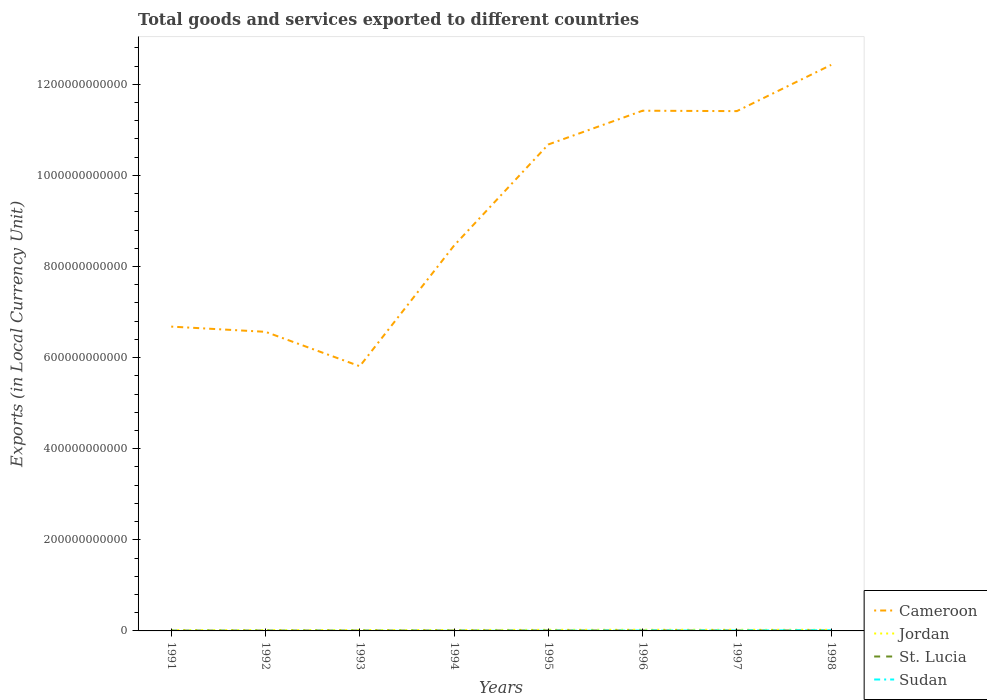Does the line corresponding to Jordan intersect with the line corresponding to St. Lucia?
Offer a very short reply. No. Is the number of lines equal to the number of legend labels?
Your answer should be compact. Yes. Across all years, what is the maximum Amount of goods and services exports in Cameroon?
Give a very brief answer. 5.81e+11. In which year was the Amount of goods and services exports in Cameroon maximum?
Give a very brief answer. 1993. What is the total Amount of goods and services exports in Jordan in the graph?
Ensure brevity in your answer.  -4.83e+08. What is the difference between the highest and the second highest Amount of goods and services exports in St. Lucia?
Provide a short and direct response. 2.23e+08. What is the difference between the highest and the lowest Amount of goods and services exports in Sudan?
Provide a short and direct response. 3. Is the Amount of goods and services exports in Sudan strictly greater than the Amount of goods and services exports in Cameroon over the years?
Provide a short and direct response. Yes. How many years are there in the graph?
Offer a terse response. 8. What is the difference between two consecutive major ticks on the Y-axis?
Offer a terse response. 2.00e+11. Does the graph contain grids?
Offer a terse response. No. How many legend labels are there?
Keep it short and to the point. 4. What is the title of the graph?
Ensure brevity in your answer.  Total goods and services exported to different countries. Does "Turks and Caicos Islands" appear as one of the legend labels in the graph?
Give a very brief answer. No. What is the label or title of the X-axis?
Offer a terse response. Years. What is the label or title of the Y-axis?
Provide a succinct answer. Exports (in Local Currency Unit). What is the Exports (in Local Currency Unit) in Cameroon in 1991?
Make the answer very short. 6.68e+11. What is the Exports (in Local Currency Unit) of Jordan in 1991?
Provide a succinct answer. 1.70e+09. What is the Exports (in Local Currency Unit) in St. Lucia in 1991?
Your answer should be very brief. 8.15e+08. What is the Exports (in Local Currency Unit) in Sudan in 1991?
Keep it short and to the point. 1.02e+07. What is the Exports (in Local Currency Unit) of Cameroon in 1992?
Make the answer very short. 6.57e+11. What is the Exports (in Local Currency Unit) in Jordan in 1992?
Ensure brevity in your answer.  1.81e+09. What is the Exports (in Local Currency Unit) in St. Lucia in 1992?
Your answer should be very brief. 8.74e+08. What is the Exports (in Local Currency Unit) of Sudan in 1992?
Your answer should be very brief. 3.59e+07. What is the Exports (in Local Currency Unit) in Cameroon in 1993?
Give a very brief answer. 5.81e+11. What is the Exports (in Local Currency Unit) of Jordan in 1993?
Provide a succinct answer. 1.96e+09. What is the Exports (in Local Currency Unit) of St. Lucia in 1993?
Provide a succinct answer. 8.99e+08. What is the Exports (in Local Currency Unit) in Sudan in 1993?
Keep it short and to the point. 5.99e+07. What is the Exports (in Local Currency Unit) of Cameroon in 1994?
Keep it short and to the point. 8.46e+11. What is the Exports (in Local Currency Unit) in Jordan in 1994?
Make the answer very short. 2.09e+09. What is the Exports (in Local Currency Unit) of St. Lucia in 1994?
Ensure brevity in your answer.  9.18e+08. What is the Exports (in Local Currency Unit) in Sudan in 1994?
Your answer should be compact. 1.74e+08. What is the Exports (in Local Currency Unit) in Cameroon in 1995?
Your answer should be very brief. 1.07e+12. What is the Exports (in Local Currency Unit) in Jordan in 1995?
Give a very brief answer. 2.44e+09. What is the Exports (in Local Currency Unit) of St. Lucia in 1995?
Make the answer very short. 1.02e+09. What is the Exports (in Local Currency Unit) of Sudan in 1995?
Ensure brevity in your answer.  3.99e+08. What is the Exports (in Local Currency Unit) in Cameroon in 1996?
Ensure brevity in your answer.  1.14e+12. What is the Exports (in Local Currency Unit) in Jordan in 1996?
Provide a short and direct response. 2.60e+09. What is the Exports (in Local Currency Unit) in St. Lucia in 1996?
Ensure brevity in your answer.  9.53e+08. What is the Exports (in Local Currency Unit) in Sudan in 1996?
Offer a very short reply. 8.41e+08. What is the Exports (in Local Currency Unit) in Cameroon in 1997?
Provide a short and direct response. 1.14e+12. What is the Exports (in Local Currency Unit) of Jordan in 1997?
Provide a short and direct response. 2.53e+09. What is the Exports (in Local Currency Unit) of St. Lucia in 1997?
Your answer should be very brief. 9.68e+08. What is the Exports (in Local Currency Unit) in Sudan in 1997?
Offer a very short reply. 9.84e+08. What is the Exports (in Local Currency Unit) in Cameroon in 1998?
Make the answer very short. 1.24e+12. What is the Exports (in Local Currency Unit) of Jordan in 1998?
Provide a short and direct response. 2.52e+09. What is the Exports (in Local Currency Unit) in St. Lucia in 1998?
Provide a short and direct response. 1.04e+09. What is the Exports (in Local Currency Unit) of Sudan in 1998?
Ensure brevity in your answer.  1.51e+09. Across all years, what is the maximum Exports (in Local Currency Unit) of Cameroon?
Ensure brevity in your answer.  1.24e+12. Across all years, what is the maximum Exports (in Local Currency Unit) of Jordan?
Ensure brevity in your answer.  2.60e+09. Across all years, what is the maximum Exports (in Local Currency Unit) of St. Lucia?
Give a very brief answer. 1.04e+09. Across all years, what is the maximum Exports (in Local Currency Unit) of Sudan?
Provide a short and direct response. 1.51e+09. Across all years, what is the minimum Exports (in Local Currency Unit) of Cameroon?
Offer a very short reply. 5.81e+11. Across all years, what is the minimum Exports (in Local Currency Unit) in Jordan?
Make the answer very short. 1.70e+09. Across all years, what is the minimum Exports (in Local Currency Unit) in St. Lucia?
Make the answer very short. 8.15e+08. Across all years, what is the minimum Exports (in Local Currency Unit) in Sudan?
Make the answer very short. 1.02e+07. What is the total Exports (in Local Currency Unit) in Cameroon in the graph?
Your answer should be compact. 7.34e+12. What is the total Exports (in Local Currency Unit) of Jordan in the graph?
Your response must be concise. 1.76e+1. What is the total Exports (in Local Currency Unit) of St. Lucia in the graph?
Provide a short and direct response. 7.49e+09. What is the total Exports (in Local Currency Unit) of Sudan in the graph?
Your answer should be compact. 4.02e+09. What is the difference between the Exports (in Local Currency Unit) in Cameroon in 1991 and that in 1992?
Offer a terse response. 1.15e+1. What is the difference between the Exports (in Local Currency Unit) of Jordan in 1991 and that in 1992?
Make the answer very short. -1.16e+08. What is the difference between the Exports (in Local Currency Unit) of St. Lucia in 1991 and that in 1992?
Offer a very short reply. -5.97e+07. What is the difference between the Exports (in Local Currency Unit) in Sudan in 1991 and that in 1992?
Offer a terse response. -2.57e+07. What is the difference between the Exports (in Local Currency Unit) in Cameroon in 1991 and that in 1993?
Ensure brevity in your answer.  8.70e+1. What is the difference between the Exports (in Local Currency Unit) of Jordan in 1991 and that in 1993?
Your answer should be compact. -2.58e+08. What is the difference between the Exports (in Local Currency Unit) of St. Lucia in 1991 and that in 1993?
Provide a succinct answer. -8.42e+07. What is the difference between the Exports (in Local Currency Unit) of Sudan in 1991 and that in 1993?
Give a very brief answer. -4.96e+07. What is the difference between the Exports (in Local Currency Unit) of Cameroon in 1991 and that in 1994?
Your answer should be compact. -1.78e+11. What is the difference between the Exports (in Local Currency Unit) in Jordan in 1991 and that in 1994?
Ensure brevity in your answer.  -3.88e+08. What is the difference between the Exports (in Local Currency Unit) of St. Lucia in 1991 and that in 1994?
Keep it short and to the point. -1.03e+08. What is the difference between the Exports (in Local Currency Unit) of Sudan in 1991 and that in 1994?
Give a very brief answer. -1.64e+08. What is the difference between the Exports (in Local Currency Unit) of Cameroon in 1991 and that in 1995?
Offer a terse response. -4.00e+11. What is the difference between the Exports (in Local Currency Unit) of Jordan in 1991 and that in 1995?
Provide a short and direct response. -7.41e+08. What is the difference between the Exports (in Local Currency Unit) of St. Lucia in 1991 and that in 1995?
Offer a very short reply. -2.08e+08. What is the difference between the Exports (in Local Currency Unit) in Sudan in 1991 and that in 1995?
Make the answer very short. -3.89e+08. What is the difference between the Exports (in Local Currency Unit) in Cameroon in 1991 and that in 1996?
Your answer should be very brief. -4.74e+11. What is the difference between the Exports (in Local Currency Unit) in Jordan in 1991 and that in 1996?
Keep it short and to the point. -9.00e+08. What is the difference between the Exports (in Local Currency Unit) in St. Lucia in 1991 and that in 1996?
Your answer should be very brief. -1.39e+08. What is the difference between the Exports (in Local Currency Unit) in Sudan in 1991 and that in 1996?
Offer a terse response. -8.31e+08. What is the difference between the Exports (in Local Currency Unit) in Cameroon in 1991 and that in 1997?
Provide a succinct answer. -4.73e+11. What is the difference between the Exports (in Local Currency Unit) of Jordan in 1991 and that in 1997?
Your response must be concise. -8.35e+08. What is the difference between the Exports (in Local Currency Unit) in St. Lucia in 1991 and that in 1997?
Your answer should be compact. -1.54e+08. What is the difference between the Exports (in Local Currency Unit) in Sudan in 1991 and that in 1997?
Your response must be concise. -9.73e+08. What is the difference between the Exports (in Local Currency Unit) of Cameroon in 1991 and that in 1998?
Give a very brief answer. -5.75e+11. What is the difference between the Exports (in Local Currency Unit) of Jordan in 1991 and that in 1998?
Offer a very short reply. -8.18e+08. What is the difference between the Exports (in Local Currency Unit) of St. Lucia in 1991 and that in 1998?
Your response must be concise. -2.23e+08. What is the difference between the Exports (in Local Currency Unit) of Sudan in 1991 and that in 1998?
Offer a very short reply. -1.50e+09. What is the difference between the Exports (in Local Currency Unit) of Cameroon in 1992 and that in 1993?
Ensure brevity in your answer.  7.55e+1. What is the difference between the Exports (in Local Currency Unit) of Jordan in 1992 and that in 1993?
Offer a terse response. -1.42e+08. What is the difference between the Exports (in Local Currency Unit) in St. Lucia in 1992 and that in 1993?
Offer a very short reply. -2.46e+07. What is the difference between the Exports (in Local Currency Unit) in Sudan in 1992 and that in 1993?
Give a very brief answer. -2.39e+07. What is the difference between the Exports (in Local Currency Unit) in Cameroon in 1992 and that in 1994?
Offer a terse response. -1.89e+11. What is the difference between the Exports (in Local Currency Unit) of Jordan in 1992 and that in 1994?
Offer a terse response. -2.72e+08. What is the difference between the Exports (in Local Currency Unit) in St. Lucia in 1992 and that in 1994?
Give a very brief answer. -4.37e+07. What is the difference between the Exports (in Local Currency Unit) in Sudan in 1992 and that in 1994?
Keep it short and to the point. -1.38e+08. What is the difference between the Exports (in Local Currency Unit) of Cameroon in 1992 and that in 1995?
Your answer should be compact. -4.11e+11. What is the difference between the Exports (in Local Currency Unit) of Jordan in 1992 and that in 1995?
Provide a succinct answer. -6.25e+08. What is the difference between the Exports (in Local Currency Unit) of St. Lucia in 1992 and that in 1995?
Ensure brevity in your answer.  -1.48e+08. What is the difference between the Exports (in Local Currency Unit) of Sudan in 1992 and that in 1995?
Your answer should be very brief. -3.63e+08. What is the difference between the Exports (in Local Currency Unit) of Cameroon in 1992 and that in 1996?
Offer a terse response. -4.85e+11. What is the difference between the Exports (in Local Currency Unit) in Jordan in 1992 and that in 1996?
Give a very brief answer. -7.84e+08. What is the difference between the Exports (in Local Currency Unit) of St. Lucia in 1992 and that in 1996?
Keep it short and to the point. -7.91e+07. What is the difference between the Exports (in Local Currency Unit) of Sudan in 1992 and that in 1996?
Offer a very short reply. -8.05e+08. What is the difference between the Exports (in Local Currency Unit) of Cameroon in 1992 and that in 1997?
Provide a succinct answer. -4.84e+11. What is the difference between the Exports (in Local Currency Unit) in Jordan in 1992 and that in 1997?
Your answer should be compact. -7.19e+08. What is the difference between the Exports (in Local Currency Unit) of St. Lucia in 1992 and that in 1997?
Your answer should be very brief. -9.42e+07. What is the difference between the Exports (in Local Currency Unit) in Sudan in 1992 and that in 1997?
Provide a succinct answer. -9.48e+08. What is the difference between the Exports (in Local Currency Unit) in Cameroon in 1992 and that in 1998?
Keep it short and to the point. -5.86e+11. What is the difference between the Exports (in Local Currency Unit) in Jordan in 1992 and that in 1998?
Your answer should be very brief. -7.02e+08. What is the difference between the Exports (in Local Currency Unit) in St. Lucia in 1992 and that in 1998?
Make the answer very short. -1.63e+08. What is the difference between the Exports (in Local Currency Unit) of Sudan in 1992 and that in 1998?
Your answer should be compact. -1.48e+09. What is the difference between the Exports (in Local Currency Unit) of Cameroon in 1993 and that in 1994?
Your answer should be very brief. -2.65e+11. What is the difference between the Exports (in Local Currency Unit) in Jordan in 1993 and that in 1994?
Offer a very short reply. -1.30e+08. What is the difference between the Exports (in Local Currency Unit) in St. Lucia in 1993 and that in 1994?
Keep it short and to the point. -1.92e+07. What is the difference between the Exports (in Local Currency Unit) in Sudan in 1993 and that in 1994?
Offer a terse response. -1.14e+08. What is the difference between the Exports (in Local Currency Unit) in Cameroon in 1993 and that in 1995?
Keep it short and to the point. -4.87e+11. What is the difference between the Exports (in Local Currency Unit) of Jordan in 1993 and that in 1995?
Offer a very short reply. -4.83e+08. What is the difference between the Exports (in Local Currency Unit) in St. Lucia in 1993 and that in 1995?
Offer a very short reply. -1.24e+08. What is the difference between the Exports (in Local Currency Unit) in Sudan in 1993 and that in 1995?
Your answer should be compact. -3.39e+08. What is the difference between the Exports (in Local Currency Unit) in Cameroon in 1993 and that in 1996?
Ensure brevity in your answer.  -5.61e+11. What is the difference between the Exports (in Local Currency Unit) of Jordan in 1993 and that in 1996?
Give a very brief answer. -6.42e+08. What is the difference between the Exports (in Local Currency Unit) in St. Lucia in 1993 and that in 1996?
Your response must be concise. -5.46e+07. What is the difference between the Exports (in Local Currency Unit) in Sudan in 1993 and that in 1996?
Your answer should be compact. -7.81e+08. What is the difference between the Exports (in Local Currency Unit) of Cameroon in 1993 and that in 1997?
Offer a very short reply. -5.60e+11. What is the difference between the Exports (in Local Currency Unit) of Jordan in 1993 and that in 1997?
Your answer should be compact. -5.78e+08. What is the difference between the Exports (in Local Currency Unit) of St. Lucia in 1993 and that in 1997?
Your answer should be very brief. -6.96e+07. What is the difference between the Exports (in Local Currency Unit) of Sudan in 1993 and that in 1997?
Provide a short and direct response. -9.24e+08. What is the difference between the Exports (in Local Currency Unit) in Cameroon in 1993 and that in 1998?
Your answer should be compact. -6.62e+11. What is the difference between the Exports (in Local Currency Unit) of Jordan in 1993 and that in 1998?
Your answer should be compact. -5.60e+08. What is the difference between the Exports (in Local Currency Unit) in St. Lucia in 1993 and that in 1998?
Your answer should be compact. -1.38e+08. What is the difference between the Exports (in Local Currency Unit) in Sudan in 1993 and that in 1998?
Ensure brevity in your answer.  -1.45e+09. What is the difference between the Exports (in Local Currency Unit) in Cameroon in 1994 and that in 1995?
Your answer should be very brief. -2.22e+11. What is the difference between the Exports (in Local Currency Unit) in Jordan in 1994 and that in 1995?
Your answer should be compact. -3.53e+08. What is the difference between the Exports (in Local Currency Unit) in St. Lucia in 1994 and that in 1995?
Your answer should be very brief. -1.05e+08. What is the difference between the Exports (in Local Currency Unit) of Sudan in 1994 and that in 1995?
Give a very brief answer. -2.25e+08. What is the difference between the Exports (in Local Currency Unit) in Cameroon in 1994 and that in 1996?
Ensure brevity in your answer.  -2.96e+11. What is the difference between the Exports (in Local Currency Unit) of Jordan in 1994 and that in 1996?
Provide a succinct answer. -5.12e+08. What is the difference between the Exports (in Local Currency Unit) of St. Lucia in 1994 and that in 1996?
Make the answer very short. -3.54e+07. What is the difference between the Exports (in Local Currency Unit) of Sudan in 1994 and that in 1996?
Your answer should be compact. -6.67e+08. What is the difference between the Exports (in Local Currency Unit) of Cameroon in 1994 and that in 1997?
Your response must be concise. -2.95e+11. What is the difference between the Exports (in Local Currency Unit) in Jordan in 1994 and that in 1997?
Your answer should be very brief. -4.47e+08. What is the difference between the Exports (in Local Currency Unit) in St. Lucia in 1994 and that in 1997?
Make the answer very short. -5.04e+07. What is the difference between the Exports (in Local Currency Unit) in Sudan in 1994 and that in 1997?
Ensure brevity in your answer.  -8.10e+08. What is the difference between the Exports (in Local Currency Unit) of Cameroon in 1994 and that in 1998?
Your response must be concise. -3.97e+11. What is the difference between the Exports (in Local Currency Unit) in Jordan in 1994 and that in 1998?
Make the answer very short. -4.30e+08. What is the difference between the Exports (in Local Currency Unit) in St. Lucia in 1994 and that in 1998?
Keep it short and to the point. -1.19e+08. What is the difference between the Exports (in Local Currency Unit) of Sudan in 1994 and that in 1998?
Provide a short and direct response. -1.34e+09. What is the difference between the Exports (in Local Currency Unit) of Cameroon in 1995 and that in 1996?
Your response must be concise. -7.41e+1. What is the difference between the Exports (in Local Currency Unit) in Jordan in 1995 and that in 1996?
Give a very brief answer. -1.59e+08. What is the difference between the Exports (in Local Currency Unit) in St. Lucia in 1995 and that in 1996?
Your answer should be very brief. 6.94e+07. What is the difference between the Exports (in Local Currency Unit) in Sudan in 1995 and that in 1996?
Make the answer very short. -4.42e+08. What is the difference between the Exports (in Local Currency Unit) of Cameroon in 1995 and that in 1997?
Provide a succinct answer. -7.32e+1. What is the difference between the Exports (in Local Currency Unit) of Jordan in 1995 and that in 1997?
Offer a terse response. -9.43e+07. What is the difference between the Exports (in Local Currency Unit) of St. Lucia in 1995 and that in 1997?
Give a very brief answer. 5.44e+07. What is the difference between the Exports (in Local Currency Unit) of Sudan in 1995 and that in 1997?
Provide a succinct answer. -5.84e+08. What is the difference between the Exports (in Local Currency Unit) in Cameroon in 1995 and that in 1998?
Provide a short and direct response. -1.75e+11. What is the difference between the Exports (in Local Currency Unit) of Jordan in 1995 and that in 1998?
Offer a very short reply. -7.72e+07. What is the difference between the Exports (in Local Currency Unit) in St. Lucia in 1995 and that in 1998?
Your answer should be compact. -1.45e+07. What is the difference between the Exports (in Local Currency Unit) of Sudan in 1995 and that in 1998?
Your answer should be very brief. -1.11e+09. What is the difference between the Exports (in Local Currency Unit) in Cameroon in 1996 and that in 1997?
Your answer should be very brief. 9.10e+08. What is the difference between the Exports (in Local Currency Unit) of Jordan in 1996 and that in 1997?
Your response must be concise. 6.44e+07. What is the difference between the Exports (in Local Currency Unit) in St. Lucia in 1996 and that in 1997?
Your answer should be very brief. -1.50e+07. What is the difference between the Exports (in Local Currency Unit) in Sudan in 1996 and that in 1997?
Your response must be concise. -1.43e+08. What is the difference between the Exports (in Local Currency Unit) in Cameroon in 1996 and that in 1998?
Ensure brevity in your answer.  -1.01e+11. What is the difference between the Exports (in Local Currency Unit) of Jordan in 1996 and that in 1998?
Ensure brevity in your answer.  8.15e+07. What is the difference between the Exports (in Local Currency Unit) in St. Lucia in 1996 and that in 1998?
Ensure brevity in your answer.  -8.39e+07. What is the difference between the Exports (in Local Currency Unit) of Sudan in 1996 and that in 1998?
Offer a terse response. -6.73e+08. What is the difference between the Exports (in Local Currency Unit) in Cameroon in 1997 and that in 1998?
Your response must be concise. -1.02e+11. What is the difference between the Exports (in Local Currency Unit) of Jordan in 1997 and that in 1998?
Make the answer very short. 1.71e+07. What is the difference between the Exports (in Local Currency Unit) in St. Lucia in 1997 and that in 1998?
Provide a short and direct response. -6.89e+07. What is the difference between the Exports (in Local Currency Unit) in Sudan in 1997 and that in 1998?
Provide a short and direct response. -5.30e+08. What is the difference between the Exports (in Local Currency Unit) of Cameroon in 1991 and the Exports (in Local Currency Unit) of Jordan in 1992?
Offer a terse response. 6.66e+11. What is the difference between the Exports (in Local Currency Unit) in Cameroon in 1991 and the Exports (in Local Currency Unit) in St. Lucia in 1992?
Offer a terse response. 6.67e+11. What is the difference between the Exports (in Local Currency Unit) of Cameroon in 1991 and the Exports (in Local Currency Unit) of Sudan in 1992?
Offer a terse response. 6.68e+11. What is the difference between the Exports (in Local Currency Unit) in Jordan in 1991 and the Exports (in Local Currency Unit) in St. Lucia in 1992?
Your answer should be very brief. 8.23e+08. What is the difference between the Exports (in Local Currency Unit) of Jordan in 1991 and the Exports (in Local Currency Unit) of Sudan in 1992?
Your answer should be compact. 1.66e+09. What is the difference between the Exports (in Local Currency Unit) in St. Lucia in 1991 and the Exports (in Local Currency Unit) in Sudan in 1992?
Your response must be concise. 7.79e+08. What is the difference between the Exports (in Local Currency Unit) of Cameroon in 1991 and the Exports (in Local Currency Unit) of Jordan in 1993?
Provide a short and direct response. 6.66e+11. What is the difference between the Exports (in Local Currency Unit) in Cameroon in 1991 and the Exports (in Local Currency Unit) in St. Lucia in 1993?
Your response must be concise. 6.67e+11. What is the difference between the Exports (in Local Currency Unit) in Cameroon in 1991 and the Exports (in Local Currency Unit) in Sudan in 1993?
Provide a succinct answer. 6.68e+11. What is the difference between the Exports (in Local Currency Unit) in Jordan in 1991 and the Exports (in Local Currency Unit) in St. Lucia in 1993?
Provide a short and direct response. 7.99e+08. What is the difference between the Exports (in Local Currency Unit) of Jordan in 1991 and the Exports (in Local Currency Unit) of Sudan in 1993?
Offer a very short reply. 1.64e+09. What is the difference between the Exports (in Local Currency Unit) of St. Lucia in 1991 and the Exports (in Local Currency Unit) of Sudan in 1993?
Give a very brief answer. 7.55e+08. What is the difference between the Exports (in Local Currency Unit) in Cameroon in 1991 and the Exports (in Local Currency Unit) in Jordan in 1994?
Keep it short and to the point. 6.66e+11. What is the difference between the Exports (in Local Currency Unit) of Cameroon in 1991 and the Exports (in Local Currency Unit) of St. Lucia in 1994?
Give a very brief answer. 6.67e+11. What is the difference between the Exports (in Local Currency Unit) of Cameroon in 1991 and the Exports (in Local Currency Unit) of Sudan in 1994?
Provide a short and direct response. 6.68e+11. What is the difference between the Exports (in Local Currency Unit) of Jordan in 1991 and the Exports (in Local Currency Unit) of St. Lucia in 1994?
Keep it short and to the point. 7.80e+08. What is the difference between the Exports (in Local Currency Unit) of Jordan in 1991 and the Exports (in Local Currency Unit) of Sudan in 1994?
Your answer should be very brief. 1.52e+09. What is the difference between the Exports (in Local Currency Unit) of St. Lucia in 1991 and the Exports (in Local Currency Unit) of Sudan in 1994?
Provide a succinct answer. 6.41e+08. What is the difference between the Exports (in Local Currency Unit) in Cameroon in 1991 and the Exports (in Local Currency Unit) in Jordan in 1995?
Provide a short and direct response. 6.66e+11. What is the difference between the Exports (in Local Currency Unit) in Cameroon in 1991 and the Exports (in Local Currency Unit) in St. Lucia in 1995?
Offer a terse response. 6.67e+11. What is the difference between the Exports (in Local Currency Unit) in Cameroon in 1991 and the Exports (in Local Currency Unit) in Sudan in 1995?
Keep it short and to the point. 6.68e+11. What is the difference between the Exports (in Local Currency Unit) of Jordan in 1991 and the Exports (in Local Currency Unit) of St. Lucia in 1995?
Your answer should be compact. 6.75e+08. What is the difference between the Exports (in Local Currency Unit) of Jordan in 1991 and the Exports (in Local Currency Unit) of Sudan in 1995?
Give a very brief answer. 1.30e+09. What is the difference between the Exports (in Local Currency Unit) of St. Lucia in 1991 and the Exports (in Local Currency Unit) of Sudan in 1995?
Offer a terse response. 4.15e+08. What is the difference between the Exports (in Local Currency Unit) of Cameroon in 1991 and the Exports (in Local Currency Unit) of Jordan in 1996?
Offer a very short reply. 6.65e+11. What is the difference between the Exports (in Local Currency Unit) of Cameroon in 1991 and the Exports (in Local Currency Unit) of St. Lucia in 1996?
Keep it short and to the point. 6.67e+11. What is the difference between the Exports (in Local Currency Unit) in Cameroon in 1991 and the Exports (in Local Currency Unit) in Sudan in 1996?
Keep it short and to the point. 6.67e+11. What is the difference between the Exports (in Local Currency Unit) in Jordan in 1991 and the Exports (in Local Currency Unit) in St. Lucia in 1996?
Offer a terse response. 7.44e+08. What is the difference between the Exports (in Local Currency Unit) of Jordan in 1991 and the Exports (in Local Currency Unit) of Sudan in 1996?
Your answer should be compact. 8.57e+08. What is the difference between the Exports (in Local Currency Unit) in St. Lucia in 1991 and the Exports (in Local Currency Unit) in Sudan in 1996?
Ensure brevity in your answer.  -2.63e+07. What is the difference between the Exports (in Local Currency Unit) in Cameroon in 1991 and the Exports (in Local Currency Unit) in Jordan in 1997?
Your response must be concise. 6.65e+11. What is the difference between the Exports (in Local Currency Unit) in Cameroon in 1991 and the Exports (in Local Currency Unit) in St. Lucia in 1997?
Make the answer very short. 6.67e+11. What is the difference between the Exports (in Local Currency Unit) in Cameroon in 1991 and the Exports (in Local Currency Unit) in Sudan in 1997?
Your response must be concise. 6.67e+11. What is the difference between the Exports (in Local Currency Unit) of Jordan in 1991 and the Exports (in Local Currency Unit) of St. Lucia in 1997?
Give a very brief answer. 7.29e+08. What is the difference between the Exports (in Local Currency Unit) of Jordan in 1991 and the Exports (in Local Currency Unit) of Sudan in 1997?
Offer a very short reply. 7.14e+08. What is the difference between the Exports (in Local Currency Unit) of St. Lucia in 1991 and the Exports (in Local Currency Unit) of Sudan in 1997?
Provide a short and direct response. -1.69e+08. What is the difference between the Exports (in Local Currency Unit) in Cameroon in 1991 and the Exports (in Local Currency Unit) in Jordan in 1998?
Provide a succinct answer. 6.65e+11. What is the difference between the Exports (in Local Currency Unit) of Cameroon in 1991 and the Exports (in Local Currency Unit) of St. Lucia in 1998?
Keep it short and to the point. 6.67e+11. What is the difference between the Exports (in Local Currency Unit) of Cameroon in 1991 and the Exports (in Local Currency Unit) of Sudan in 1998?
Provide a short and direct response. 6.66e+11. What is the difference between the Exports (in Local Currency Unit) of Jordan in 1991 and the Exports (in Local Currency Unit) of St. Lucia in 1998?
Your answer should be very brief. 6.60e+08. What is the difference between the Exports (in Local Currency Unit) of Jordan in 1991 and the Exports (in Local Currency Unit) of Sudan in 1998?
Ensure brevity in your answer.  1.84e+08. What is the difference between the Exports (in Local Currency Unit) of St. Lucia in 1991 and the Exports (in Local Currency Unit) of Sudan in 1998?
Your response must be concise. -6.99e+08. What is the difference between the Exports (in Local Currency Unit) of Cameroon in 1992 and the Exports (in Local Currency Unit) of Jordan in 1993?
Your answer should be very brief. 6.55e+11. What is the difference between the Exports (in Local Currency Unit) of Cameroon in 1992 and the Exports (in Local Currency Unit) of St. Lucia in 1993?
Provide a short and direct response. 6.56e+11. What is the difference between the Exports (in Local Currency Unit) in Cameroon in 1992 and the Exports (in Local Currency Unit) in Sudan in 1993?
Give a very brief answer. 6.56e+11. What is the difference between the Exports (in Local Currency Unit) in Jordan in 1992 and the Exports (in Local Currency Unit) in St. Lucia in 1993?
Make the answer very short. 9.15e+08. What is the difference between the Exports (in Local Currency Unit) of Jordan in 1992 and the Exports (in Local Currency Unit) of Sudan in 1993?
Offer a very short reply. 1.75e+09. What is the difference between the Exports (in Local Currency Unit) of St. Lucia in 1992 and the Exports (in Local Currency Unit) of Sudan in 1993?
Make the answer very short. 8.14e+08. What is the difference between the Exports (in Local Currency Unit) in Cameroon in 1992 and the Exports (in Local Currency Unit) in Jordan in 1994?
Make the answer very short. 6.54e+11. What is the difference between the Exports (in Local Currency Unit) of Cameroon in 1992 and the Exports (in Local Currency Unit) of St. Lucia in 1994?
Give a very brief answer. 6.56e+11. What is the difference between the Exports (in Local Currency Unit) of Cameroon in 1992 and the Exports (in Local Currency Unit) of Sudan in 1994?
Your response must be concise. 6.56e+11. What is the difference between the Exports (in Local Currency Unit) of Jordan in 1992 and the Exports (in Local Currency Unit) of St. Lucia in 1994?
Provide a succinct answer. 8.96e+08. What is the difference between the Exports (in Local Currency Unit) of Jordan in 1992 and the Exports (in Local Currency Unit) of Sudan in 1994?
Your answer should be compact. 1.64e+09. What is the difference between the Exports (in Local Currency Unit) in St. Lucia in 1992 and the Exports (in Local Currency Unit) in Sudan in 1994?
Provide a short and direct response. 7.00e+08. What is the difference between the Exports (in Local Currency Unit) of Cameroon in 1992 and the Exports (in Local Currency Unit) of Jordan in 1995?
Ensure brevity in your answer.  6.54e+11. What is the difference between the Exports (in Local Currency Unit) in Cameroon in 1992 and the Exports (in Local Currency Unit) in St. Lucia in 1995?
Offer a terse response. 6.56e+11. What is the difference between the Exports (in Local Currency Unit) of Cameroon in 1992 and the Exports (in Local Currency Unit) of Sudan in 1995?
Provide a succinct answer. 6.56e+11. What is the difference between the Exports (in Local Currency Unit) of Jordan in 1992 and the Exports (in Local Currency Unit) of St. Lucia in 1995?
Make the answer very short. 7.91e+08. What is the difference between the Exports (in Local Currency Unit) in Jordan in 1992 and the Exports (in Local Currency Unit) in Sudan in 1995?
Offer a very short reply. 1.41e+09. What is the difference between the Exports (in Local Currency Unit) in St. Lucia in 1992 and the Exports (in Local Currency Unit) in Sudan in 1995?
Your response must be concise. 4.75e+08. What is the difference between the Exports (in Local Currency Unit) of Cameroon in 1992 and the Exports (in Local Currency Unit) of Jordan in 1996?
Provide a succinct answer. 6.54e+11. What is the difference between the Exports (in Local Currency Unit) in Cameroon in 1992 and the Exports (in Local Currency Unit) in St. Lucia in 1996?
Offer a terse response. 6.56e+11. What is the difference between the Exports (in Local Currency Unit) of Cameroon in 1992 and the Exports (in Local Currency Unit) of Sudan in 1996?
Offer a very short reply. 6.56e+11. What is the difference between the Exports (in Local Currency Unit) in Jordan in 1992 and the Exports (in Local Currency Unit) in St. Lucia in 1996?
Your response must be concise. 8.60e+08. What is the difference between the Exports (in Local Currency Unit) of Jordan in 1992 and the Exports (in Local Currency Unit) of Sudan in 1996?
Your response must be concise. 9.73e+08. What is the difference between the Exports (in Local Currency Unit) of St. Lucia in 1992 and the Exports (in Local Currency Unit) of Sudan in 1996?
Ensure brevity in your answer.  3.34e+07. What is the difference between the Exports (in Local Currency Unit) in Cameroon in 1992 and the Exports (in Local Currency Unit) in Jordan in 1997?
Ensure brevity in your answer.  6.54e+11. What is the difference between the Exports (in Local Currency Unit) of Cameroon in 1992 and the Exports (in Local Currency Unit) of St. Lucia in 1997?
Keep it short and to the point. 6.56e+11. What is the difference between the Exports (in Local Currency Unit) in Cameroon in 1992 and the Exports (in Local Currency Unit) in Sudan in 1997?
Your answer should be compact. 6.56e+11. What is the difference between the Exports (in Local Currency Unit) in Jordan in 1992 and the Exports (in Local Currency Unit) in St. Lucia in 1997?
Offer a terse response. 8.45e+08. What is the difference between the Exports (in Local Currency Unit) of Jordan in 1992 and the Exports (in Local Currency Unit) of Sudan in 1997?
Provide a succinct answer. 8.30e+08. What is the difference between the Exports (in Local Currency Unit) of St. Lucia in 1992 and the Exports (in Local Currency Unit) of Sudan in 1997?
Give a very brief answer. -1.09e+08. What is the difference between the Exports (in Local Currency Unit) of Cameroon in 1992 and the Exports (in Local Currency Unit) of Jordan in 1998?
Give a very brief answer. 6.54e+11. What is the difference between the Exports (in Local Currency Unit) of Cameroon in 1992 and the Exports (in Local Currency Unit) of St. Lucia in 1998?
Offer a very short reply. 6.56e+11. What is the difference between the Exports (in Local Currency Unit) of Cameroon in 1992 and the Exports (in Local Currency Unit) of Sudan in 1998?
Your answer should be compact. 6.55e+11. What is the difference between the Exports (in Local Currency Unit) in Jordan in 1992 and the Exports (in Local Currency Unit) in St. Lucia in 1998?
Offer a very short reply. 7.76e+08. What is the difference between the Exports (in Local Currency Unit) in Jordan in 1992 and the Exports (in Local Currency Unit) in Sudan in 1998?
Your answer should be compact. 3.00e+08. What is the difference between the Exports (in Local Currency Unit) in St. Lucia in 1992 and the Exports (in Local Currency Unit) in Sudan in 1998?
Offer a very short reply. -6.40e+08. What is the difference between the Exports (in Local Currency Unit) in Cameroon in 1993 and the Exports (in Local Currency Unit) in Jordan in 1994?
Offer a very short reply. 5.79e+11. What is the difference between the Exports (in Local Currency Unit) in Cameroon in 1993 and the Exports (in Local Currency Unit) in St. Lucia in 1994?
Your response must be concise. 5.80e+11. What is the difference between the Exports (in Local Currency Unit) of Cameroon in 1993 and the Exports (in Local Currency Unit) of Sudan in 1994?
Your answer should be compact. 5.81e+11. What is the difference between the Exports (in Local Currency Unit) of Jordan in 1993 and the Exports (in Local Currency Unit) of St. Lucia in 1994?
Offer a terse response. 1.04e+09. What is the difference between the Exports (in Local Currency Unit) of Jordan in 1993 and the Exports (in Local Currency Unit) of Sudan in 1994?
Keep it short and to the point. 1.78e+09. What is the difference between the Exports (in Local Currency Unit) of St. Lucia in 1993 and the Exports (in Local Currency Unit) of Sudan in 1994?
Keep it short and to the point. 7.25e+08. What is the difference between the Exports (in Local Currency Unit) in Cameroon in 1993 and the Exports (in Local Currency Unit) in Jordan in 1995?
Your answer should be compact. 5.79e+11. What is the difference between the Exports (in Local Currency Unit) of Cameroon in 1993 and the Exports (in Local Currency Unit) of St. Lucia in 1995?
Give a very brief answer. 5.80e+11. What is the difference between the Exports (in Local Currency Unit) of Cameroon in 1993 and the Exports (in Local Currency Unit) of Sudan in 1995?
Keep it short and to the point. 5.81e+11. What is the difference between the Exports (in Local Currency Unit) of Jordan in 1993 and the Exports (in Local Currency Unit) of St. Lucia in 1995?
Your answer should be compact. 9.32e+08. What is the difference between the Exports (in Local Currency Unit) of Jordan in 1993 and the Exports (in Local Currency Unit) of Sudan in 1995?
Provide a short and direct response. 1.56e+09. What is the difference between the Exports (in Local Currency Unit) in St. Lucia in 1993 and the Exports (in Local Currency Unit) in Sudan in 1995?
Your response must be concise. 5.00e+08. What is the difference between the Exports (in Local Currency Unit) of Cameroon in 1993 and the Exports (in Local Currency Unit) of Jordan in 1996?
Ensure brevity in your answer.  5.78e+11. What is the difference between the Exports (in Local Currency Unit) of Cameroon in 1993 and the Exports (in Local Currency Unit) of St. Lucia in 1996?
Provide a succinct answer. 5.80e+11. What is the difference between the Exports (in Local Currency Unit) in Cameroon in 1993 and the Exports (in Local Currency Unit) in Sudan in 1996?
Your response must be concise. 5.80e+11. What is the difference between the Exports (in Local Currency Unit) of Jordan in 1993 and the Exports (in Local Currency Unit) of St. Lucia in 1996?
Keep it short and to the point. 1.00e+09. What is the difference between the Exports (in Local Currency Unit) in Jordan in 1993 and the Exports (in Local Currency Unit) in Sudan in 1996?
Provide a succinct answer. 1.11e+09. What is the difference between the Exports (in Local Currency Unit) of St. Lucia in 1993 and the Exports (in Local Currency Unit) of Sudan in 1996?
Your answer should be compact. 5.79e+07. What is the difference between the Exports (in Local Currency Unit) in Cameroon in 1993 and the Exports (in Local Currency Unit) in Jordan in 1997?
Provide a succinct answer. 5.78e+11. What is the difference between the Exports (in Local Currency Unit) in Cameroon in 1993 and the Exports (in Local Currency Unit) in St. Lucia in 1997?
Make the answer very short. 5.80e+11. What is the difference between the Exports (in Local Currency Unit) in Cameroon in 1993 and the Exports (in Local Currency Unit) in Sudan in 1997?
Your response must be concise. 5.80e+11. What is the difference between the Exports (in Local Currency Unit) of Jordan in 1993 and the Exports (in Local Currency Unit) of St. Lucia in 1997?
Make the answer very short. 9.87e+08. What is the difference between the Exports (in Local Currency Unit) in Jordan in 1993 and the Exports (in Local Currency Unit) in Sudan in 1997?
Offer a terse response. 9.72e+08. What is the difference between the Exports (in Local Currency Unit) in St. Lucia in 1993 and the Exports (in Local Currency Unit) in Sudan in 1997?
Give a very brief answer. -8.47e+07. What is the difference between the Exports (in Local Currency Unit) of Cameroon in 1993 and the Exports (in Local Currency Unit) of Jordan in 1998?
Keep it short and to the point. 5.78e+11. What is the difference between the Exports (in Local Currency Unit) in Cameroon in 1993 and the Exports (in Local Currency Unit) in St. Lucia in 1998?
Offer a very short reply. 5.80e+11. What is the difference between the Exports (in Local Currency Unit) in Cameroon in 1993 and the Exports (in Local Currency Unit) in Sudan in 1998?
Provide a succinct answer. 5.79e+11. What is the difference between the Exports (in Local Currency Unit) in Jordan in 1993 and the Exports (in Local Currency Unit) in St. Lucia in 1998?
Offer a very short reply. 9.18e+08. What is the difference between the Exports (in Local Currency Unit) in Jordan in 1993 and the Exports (in Local Currency Unit) in Sudan in 1998?
Give a very brief answer. 4.41e+08. What is the difference between the Exports (in Local Currency Unit) in St. Lucia in 1993 and the Exports (in Local Currency Unit) in Sudan in 1998?
Make the answer very short. -6.15e+08. What is the difference between the Exports (in Local Currency Unit) in Cameroon in 1994 and the Exports (in Local Currency Unit) in Jordan in 1995?
Your response must be concise. 8.43e+11. What is the difference between the Exports (in Local Currency Unit) of Cameroon in 1994 and the Exports (in Local Currency Unit) of St. Lucia in 1995?
Your response must be concise. 8.45e+11. What is the difference between the Exports (in Local Currency Unit) of Cameroon in 1994 and the Exports (in Local Currency Unit) of Sudan in 1995?
Your answer should be very brief. 8.45e+11. What is the difference between the Exports (in Local Currency Unit) in Jordan in 1994 and the Exports (in Local Currency Unit) in St. Lucia in 1995?
Keep it short and to the point. 1.06e+09. What is the difference between the Exports (in Local Currency Unit) of Jordan in 1994 and the Exports (in Local Currency Unit) of Sudan in 1995?
Your answer should be compact. 1.69e+09. What is the difference between the Exports (in Local Currency Unit) in St. Lucia in 1994 and the Exports (in Local Currency Unit) in Sudan in 1995?
Your answer should be compact. 5.19e+08. What is the difference between the Exports (in Local Currency Unit) in Cameroon in 1994 and the Exports (in Local Currency Unit) in Jordan in 1996?
Your answer should be compact. 8.43e+11. What is the difference between the Exports (in Local Currency Unit) of Cameroon in 1994 and the Exports (in Local Currency Unit) of St. Lucia in 1996?
Provide a succinct answer. 8.45e+11. What is the difference between the Exports (in Local Currency Unit) in Cameroon in 1994 and the Exports (in Local Currency Unit) in Sudan in 1996?
Give a very brief answer. 8.45e+11. What is the difference between the Exports (in Local Currency Unit) of Jordan in 1994 and the Exports (in Local Currency Unit) of St. Lucia in 1996?
Your response must be concise. 1.13e+09. What is the difference between the Exports (in Local Currency Unit) in Jordan in 1994 and the Exports (in Local Currency Unit) in Sudan in 1996?
Offer a very short reply. 1.24e+09. What is the difference between the Exports (in Local Currency Unit) of St. Lucia in 1994 and the Exports (in Local Currency Unit) of Sudan in 1996?
Ensure brevity in your answer.  7.71e+07. What is the difference between the Exports (in Local Currency Unit) in Cameroon in 1994 and the Exports (in Local Currency Unit) in Jordan in 1997?
Offer a very short reply. 8.43e+11. What is the difference between the Exports (in Local Currency Unit) of Cameroon in 1994 and the Exports (in Local Currency Unit) of St. Lucia in 1997?
Make the answer very short. 8.45e+11. What is the difference between the Exports (in Local Currency Unit) in Cameroon in 1994 and the Exports (in Local Currency Unit) in Sudan in 1997?
Provide a succinct answer. 8.45e+11. What is the difference between the Exports (in Local Currency Unit) in Jordan in 1994 and the Exports (in Local Currency Unit) in St. Lucia in 1997?
Offer a very short reply. 1.12e+09. What is the difference between the Exports (in Local Currency Unit) in Jordan in 1994 and the Exports (in Local Currency Unit) in Sudan in 1997?
Make the answer very short. 1.10e+09. What is the difference between the Exports (in Local Currency Unit) of St. Lucia in 1994 and the Exports (in Local Currency Unit) of Sudan in 1997?
Keep it short and to the point. -6.56e+07. What is the difference between the Exports (in Local Currency Unit) of Cameroon in 1994 and the Exports (in Local Currency Unit) of Jordan in 1998?
Provide a succinct answer. 8.43e+11. What is the difference between the Exports (in Local Currency Unit) of Cameroon in 1994 and the Exports (in Local Currency Unit) of St. Lucia in 1998?
Your answer should be very brief. 8.45e+11. What is the difference between the Exports (in Local Currency Unit) in Cameroon in 1994 and the Exports (in Local Currency Unit) in Sudan in 1998?
Give a very brief answer. 8.44e+11. What is the difference between the Exports (in Local Currency Unit) of Jordan in 1994 and the Exports (in Local Currency Unit) of St. Lucia in 1998?
Your answer should be very brief. 1.05e+09. What is the difference between the Exports (in Local Currency Unit) in Jordan in 1994 and the Exports (in Local Currency Unit) in Sudan in 1998?
Give a very brief answer. 5.71e+08. What is the difference between the Exports (in Local Currency Unit) in St. Lucia in 1994 and the Exports (in Local Currency Unit) in Sudan in 1998?
Provide a short and direct response. -5.96e+08. What is the difference between the Exports (in Local Currency Unit) in Cameroon in 1995 and the Exports (in Local Currency Unit) in Jordan in 1996?
Provide a short and direct response. 1.07e+12. What is the difference between the Exports (in Local Currency Unit) of Cameroon in 1995 and the Exports (in Local Currency Unit) of St. Lucia in 1996?
Keep it short and to the point. 1.07e+12. What is the difference between the Exports (in Local Currency Unit) of Cameroon in 1995 and the Exports (in Local Currency Unit) of Sudan in 1996?
Ensure brevity in your answer.  1.07e+12. What is the difference between the Exports (in Local Currency Unit) of Jordan in 1995 and the Exports (in Local Currency Unit) of St. Lucia in 1996?
Your answer should be compact. 1.49e+09. What is the difference between the Exports (in Local Currency Unit) in Jordan in 1995 and the Exports (in Local Currency Unit) in Sudan in 1996?
Your answer should be compact. 1.60e+09. What is the difference between the Exports (in Local Currency Unit) in St. Lucia in 1995 and the Exports (in Local Currency Unit) in Sudan in 1996?
Give a very brief answer. 1.82e+08. What is the difference between the Exports (in Local Currency Unit) in Cameroon in 1995 and the Exports (in Local Currency Unit) in Jordan in 1997?
Your answer should be compact. 1.07e+12. What is the difference between the Exports (in Local Currency Unit) of Cameroon in 1995 and the Exports (in Local Currency Unit) of St. Lucia in 1997?
Give a very brief answer. 1.07e+12. What is the difference between the Exports (in Local Currency Unit) of Cameroon in 1995 and the Exports (in Local Currency Unit) of Sudan in 1997?
Make the answer very short. 1.07e+12. What is the difference between the Exports (in Local Currency Unit) of Jordan in 1995 and the Exports (in Local Currency Unit) of St. Lucia in 1997?
Provide a succinct answer. 1.47e+09. What is the difference between the Exports (in Local Currency Unit) of Jordan in 1995 and the Exports (in Local Currency Unit) of Sudan in 1997?
Provide a short and direct response. 1.45e+09. What is the difference between the Exports (in Local Currency Unit) in St. Lucia in 1995 and the Exports (in Local Currency Unit) in Sudan in 1997?
Provide a short and direct response. 3.92e+07. What is the difference between the Exports (in Local Currency Unit) in Cameroon in 1995 and the Exports (in Local Currency Unit) in Jordan in 1998?
Provide a succinct answer. 1.07e+12. What is the difference between the Exports (in Local Currency Unit) of Cameroon in 1995 and the Exports (in Local Currency Unit) of St. Lucia in 1998?
Offer a very short reply. 1.07e+12. What is the difference between the Exports (in Local Currency Unit) of Cameroon in 1995 and the Exports (in Local Currency Unit) of Sudan in 1998?
Offer a terse response. 1.07e+12. What is the difference between the Exports (in Local Currency Unit) of Jordan in 1995 and the Exports (in Local Currency Unit) of St. Lucia in 1998?
Ensure brevity in your answer.  1.40e+09. What is the difference between the Exports (in Local Currency Unit) in Jordan in 1995 and the Exports (in Local Currency Unit) in Sudan in 1998?
Make the answer very short. 9.24e+08. What is the difference between the Exports (in Local Currency Unit) of St. Lucia in 1995 and the Exports (in Local Currency Unit) of Sudan in 1998?
Provide a succinct answer. -4.91e+08. What is the difference between the Exports (in Local Currency Unit) in Cameroon in 1996 and the Exports (in Local Currency Unit) in Jordan in 1997?
Ensure brevity in your answer.  1.14e+12. What is the difference between the Exports (in Local Currency Unit) of Cameroon in 1996 and the Exports (in Local Currency Unit) of St. Lucia in 1997?
Offer a terse response. 1.14e+12. What is the difference between the Exports (in Local Currency Unit) in Cameroon in 1996 and the Exports (in Local Currency Unit) in Sudan in 1997?
Offer a very short reply. 1.14e+12. What is the difference between the Exports (in Local Currency Unit) of Jordan in 1996 and the Exports (in Local Currency Unit) of St. Lucia in 1997?
Your answer should be very brief. 1.63e+09. What is the difference between the Exports (in Local Currency Unit) in Jordan in 1996 and the Exports (in Local Currency Unit) in Sudan in 1997?
Make the answer very short. 1.61e+09. What is the difference between the Exports (in Local Currency Unit) in St. Lucia in 1996 and the Exports (in Local Currency Unit) in Sudan in 1997?
Give a very brief answer. -3.02e+07. What is the difference between the Exports (in Local Currency Unit) in Cameroon in 1996 and the Exports (in Local Currency Unit) in Jordan in 1998?
Give a very brief answer. 1.14e+12. What is the difference between the Exports (in Local Currency Unit) of Cameroon in 1996 and the Exports (in Local Currency Unit) of St. Lucia in 1998?
Make the answer very short. 1.14e+12. What is the difference between the Exports (in Local Currency Unit) of Cameroon in 1996 and the Exports (in Local Currency Unit) of Sudan in 1998?
Your response must be concise. 1.14e+12. What is the difference between the Exports (in Local Currency Unit) of Jordan in 1996 and the Exports (in Local Currency Unit) of St. Lucia in 1998?
Your response must be concise. 1.56e+09. What is the difference between the Exports (in Local Currency Unit) in Jordan in 1996 and the Exports (in Local Currency Unit) in Sudan in 1998?
Provide a succinct answer. 1.08e+09. What is the difference between the Exports (in Local Currency Unit) of St. Lucia in 1996 and the Exports (in Local Currency Unit) of Sudan in 1998?
Your response must be concise. -5.61e+08. What is the difference between the Exports (in Local Currency Unit) of Cameroon in 1997 and the Exports (in Local Currency Unit) of Jordan in 1998?
Give a very brief answer. 1.14e+12. What is the difference between the Exports (in Local Currency Unit) in Cameroon in 1997 and the Exports (in Local Currency Unit) in St. Lucia in 1998?
Provide a succinct answer. 1.14e+12. What is the difference between the Exports (in Local Currency Unit) of Cameroon in 1997 and the Exports (in Local Currency Unit) of Sudan in 1998?
Your answer should be compact. 1.14e+12. What is the difference between the Exports (in Local Currency Unit) in Jordan in 1997 and the Exports (in Local Currency Unit) in St. Lucia in 1998?
Your answer should be compact. 1.50e+09. What is the difference between the Exports (in Local Currency Unit) of Jordan in 1997 and the Exports (in Local Currency Unit) of Sudan in 1998?
Your answer should be compact. 1.02e+09. What is the difference between the Exports (in Local Currency Unit) in St. Lucia in 1997 and the Exports (in Local Currency Unit) in Sudan in 1998?
Provide a succinct answer. -5.46e+08. What is the average Exports (in Local Currency Unit) in Cameroon per year?
Offer a very short reply. 9.18e+11. What is the average Exports (in Local Currency Unit) in Jordan per year?
Provide a succinct answer. 2.20e+09. What is the average Exports (in Local Currency Unit) of St. Lucia per year?
Provide a succinct answer. 9.36e+08. What is the average Exports (in Local Currency Unit) in Sudan per year?
Provide a short and direct response. 5.02e+08. In the year 1991, what is the difference between the Exports (in Local Currency Unit) of Cameroon and Exports (in Local Currency Unit) of Jordan?
Provide a succinct answer. 6.66e+11. In the year 1991, what is the difference between the Exports (in Local Currency Unit) in Cameroon and Exports (in Local Currency Unit) in St. Lucia?
Your answer should be very brief. 6.67e+11. In the year 1991, what is the difference between the Exports (in Local Currency Unit) in Cameroon and Exports (in Local Currency Unit) in Sudan?
Offer a terse response. 6.68e+11. In the year 1991, what is the difference between the Exports (in Local Currency Unit) in Jordan and Exports (in Local Currency Unit) in St. Lucia?
Provide a short and direct response. 8.83e+08. In the year 1991, what is the difference between the Exports (in Local Currency Unit) of Jordan and Exports (in Local Currency Unit) of Sudan?
Offer a terse response. 1.69e+09. In the year 1991, what is the difference between the Exports (in Local Currency Unit) of St. Lucia and Exports (in Local Currency Unit) of Sudan?
Your answer should be compact. 8.04e+08. In the year 1992, what is the difference between the Exports (in Local Currency Unit) in Cameroon and Exports (in Local Currency Unit) in Jordan?
Your response must be concise. 6.55e+11. In the year 1992, what is the difference between the Exports (in Local Currency Unit) in Cameroon and Exports (in Local Currency Unit) in St. Lucia?
Your answer should be very brief. 6.56e+11. In the year 1992, what is the difference between the Exports (in Local Currency Unit) of Cameroon and Exports (in Local Currency Unit) of Sudan?
Offer a terse response. 6.57e+11. In the year 1992, what is the difference between the Exports (in Local Currency Unit) of Jordan and Exports (in Local Currency Unit) of St. Lucia?
Provide a succinct answer. 9.39e+08. In the year 1992, what is the difference between the Exports (in Local Currency Unit) in Jordan and Exports (in Local Currency Unit) in Sudan?
Your response must be concise. 1.78e+09. In the year 1992, what is the difference between the Exports (in Local Currency Unit) of St. Lucia and Exports (in Local Currency Unit) of Sudan?
Make the answer very short. 8.38e+08. In the year 1993, what is the difference between the Exports (in Local Currency Unit) in Cameroon and Exports (in Local Currency Unit) in Jordan?
Your response must be concise. 5.79e+11. In the year 1993, what is the difference between the Exports (in Local Currency Unit) in Cameroon and Exports (in Local Currency Unit) in St. Lucia?
Provide a succinct answer. 5.80e+11. In the year 1993, what is the difference between the Exports (in Local Currency Unit) of Cameroon and Exports (in Local Currency Unit) of Sudan?
Give a very brief answer. 5.81e+11. In the year 1993, what is the difference between the Exports (in Local Currency Unit) in Jordan and Exports (in Local Currency Unit) in St. Lucia?
Provide a short and direct response. 1.06e+09. In the year 1993, what is the difference between the Exports (in Local Currency Unit) of Jordan and Exports (in Local Currency Unit) of Sudan?
Offer a very short reply. 1.90e+09. In the year 1993, what is the difference between the Exports (in Local Currency Unit) in St. Lucia and Exports (in Local Currency Unit) in Sudan?
Make the answer very short. 8.39e+08. In the year 1994, what is the difference between the Exports (in Local Currency Unit) of Cameroon and Exports (in Local Currency Unit) of Jordan?
Give a very brief answer. 8.44e+11. In the year 1994, what is the difference between the Exports (in Local Currency Unit) of Cameroon and Exports (in Local Currency Unit) of St. Lucia?
Your answer should be very brief. 8.45e+11. In the year 1994, what is the difference between the Exports (in Local Currency Unit) in Cameroon and Exports (in Local Currency Unit) in Sudan?
Your answer should be compact. 8.46e+11. In the year 1994, what is the difference between the Exports (in Local Currency Unit) of Jordan and Exports (in Local Currency Unit) of St. Lucia?
Provide a short and direct response. 1.17e+09. In the year 1994, what is the difference between the Exports (in Local Currency Unit) of Jordan and Exports (in Local Currency Unit) of Sudan?
Offer a terse response. 1.91e+09. In the year 1994, what is the difference between the Exports (in Local Currency Unit) in St. Lucia and Exports (in Local Currency Unit) in Sudan?
Provide a short and direct response. 7.44e+08. In the year 1995, what is the difference between the Exports (in Local Currency Unit) of Cameroon and Exports (in Local Currency Unit) of Jordan?
Ensure brevity in your answer.  1.07e+12. In the year 1995, what is the difference between the Exports (in Local Currency Unit) of Cameroon and Exports (in Local Currency Unit) of St. Lucia?
Offer a very short reply. 1.07e+12. In the year 1995, what is the difference between the Exports (in Local Currency Unit) of Cameroon and Exports (in Local Currency Unit) of Sudan?
Your response must be concise. 1.07e+12. In the year 1995, what is the difference between the Exports (in Local Currency Unit) in Jordan and Exports (in Local Currency Unit) in St. Lucia?
Provide a succinct answer. 1.42e+09. In the year 1995, what is the difference between the Exports (in Local Currency Unit) in Jordan and Exports (in Local Currency Unit) in Sudan?
Your answer should be compact. 2.04e+09. In the year 1995, what is the difference between the Exports (in Local Currency Unit) of St. Lucia and Exports (in Local Currency Unit) of Sudan?
Make the answer very short. 6.24e+08. In the year 1996, what is the difference between the Exports (in Local Currency Unit) in Cameroon and Exports (in Local Currency Unit) in Jordan?
Make the answer very short. 1.14e+12. In the year 1996, what is the difference between the Exports (in Local Currency Unit) in Cameroon and Exports (in Local Currency Unit) in St. Lucia?
Your answer should be very brief. 1.14e+12. In the year 1996, what is the difference between the Exports (in Local Currency Unit) of Cameroon and Exports (in Local Currency Unit) of Sudan?
Ensure brevity in your answer.  1.14e+12. In the year 1996, what is the difference between the Exports (in Local Currency Unit) in Jordan and Exports (in Local Currency Unit) in St. Lucia?
Make the answer very short. 1.64e+09. In the year 1996, what is the difference between the Exports (in Local Currency Unit) in Jordan and Exports (in Local Currency Unit) in Sudan?
Keep it short and to the point. 1.76e+09. In the year 1996, what is the difference between the Exports (in Local Currency Unit) in St. Lucia and Exports (in Local Currency Unit) in Sudan?
Your answer should be very brief. 1.12e+08. In the year 1997, what is the difference between the Exports (in Local Currency Unit) of Cameroon and Exports (in Local Currency Unit) of Jordan?
Ensure brevity in your answer.  1.14e+12. In the year 1997, what is the difference between the Exports (in Local Currency Unit) of Cameroon and Exports (in Local Currency Unit) of St. Lucia?
Offer a very short reply. 1.14e+12. In the year 1997, what is the difference between the Exports (in Local Currency Unit) of Cameroon and Exports (in Local Currency Unit) of Sudan?
Your answer should be very brief. 1.14e+12. In the year 1997, what is the difference between the Exports (in Local Currency Unit) in Jordan and Exports (in Local Currency Unit) in St. Lucia?
Your answer should be compact. 1.56e+09. In the year 1997, what is the difference between the Exports (in Local Currency Unit) of Jordan and Exports (in Local Currency Unit) of Sudan?
Your answer should be compact. 1.55e+09. In the year 1997, what is the difference between the Exports (in Local Currency Unit) in St. Lucia and Exports (in Local Currency Unit) in Sudan?
Keep it short and to the point. -1.52e+07. In the year 1998, what is the difference between the Exports (in Local Currency Unit) of Cameroon and Exports (in Local Currency Unit) of Jordan?
Your response must be concise. 1.24e+12. In the year 1998, what is the difference between the Exports (in Local Currency Unit) in Cameroon and Exports (in Local Currency Unit) in St. Lucia?
Give a very brief answer. 1.24e+12. In the year 1998, what is the difference between the Exports (in Local Currency Unit) in Cameroon and Exports (in Local Currency Unit) in Sudan?
Provide a short and direct response. 1.24e+12. In the year 1998, what is the difference between the Exports (in Local Currency Unit) of Jordan and Exports (in Local Currency Unit) of St. Lucia?
Your answer should be very brief. 1.48e+09. In the year 1998, what is the difference between the Exports (in Local Currency Unit) in Jordan and Exports (in Local Currency Unit) in Sudan?
Offer a very short reply. 1.00e+09. In the year 1998, what is the difference between the Exports (in Local Currency Unit) of St. Lucia and Exports (in Local Currency Unit) of Sudan?
Provide a succinct answer. -4.77e+08. What is the ratio of the Exports (in Local Currency Unit) in Cameroon in 1991 to that in 1992?
Ensure brevity in your answer.  1.02. What is the ratio of the Exports (in Local Currency Unit) in Jordan in 1991 to that in 1992?
Ensure brevity in your answer.  0.94. What is the ratio of the Exports (in Local Currency Unit) in St. Lucia in 1991 to that in 1992?
Keep it short and to the point. 0.93. What is the ratio of the Exports (in Local Currency Unit) of Sudan in 1991 to that in 1992?
Keep it short and to the point. 0.29. What is the ratio of the Exports (in Local Currency Unit) of Cameroon in 1991 to that in 1993?
Provide a succinct answer. 1.15. What is the ratio of the Exports (in Local Currency Unit) of Jordan in 1991 to that in 1993?
Offer a terse response. 0.87. What is the ratio of the Exports (in Local Currency Unit) of St. Lucia in 1991 to that in 1993?
Keep it short and to the point. 0.91. What is the ratio of the Exports (in Local Currency Unit) of Sudan in 1991 to that in 1993?
Your answer should be very brief. 0.17. What is the ratio of the Exports (in Local Currency Unit) of Cameroon in 1991 to that in 1994?
Provide a short and direct response. 0.79. What is the ratio of the Exports (in Local Currency Unit) in Jordan in 1991 to that in 1994?
Provide a short and direct response. 0.81. What is the ratio of the Exports (in Local Currency Unit) of St. Lucia in 1991 to that in 1994?
Offer a terse response. 0.89. What is the ratio of the Exports (in Local Currency Unit) of Sudan in 1991 to that in 1994?
Offer a very short reply. 0.06. What is the ratio of the Exports (in Local Currency Unit) of Cameroon in 1991 to that in 1995?
Keep it short and to the point. 0.63. What is the ratio of the Exports (in Local Currency Unit) in Jordan in 1991 to that in 1995?
Your answer should be compact. 0.7. What is the ratio of the Exports (in Local Currency Unit) in St. Lucia in 1991 to that in 1995?
Your response must be concise. 0.8. What is the ratio of the Exports (in Local Currency Unit) in Sudan in 1991 to that in 1995?
Your response must be concise. 0.03. What is the ratio of the Exports (in Local Currency Unit) in Cameroon in 1991 to that in 1996?
Your response must be concise. 0.58. What is the ratio of the Exports (in Local Currency Unit) of Jordan in 1991 to that in 1996?
Offer a very short reply. 0.65. What is the ratio of the Exports (in Local Currency Unit) of St. Lucia in 1991 to that in 1996?
Your response must be concise. 0.85. What is the ratio of the Exports (in Local Currency Unit) of Sudan in 1991 to that in 1996?
Your answer should be very brief. 0.01. What is the ratio of the Exports (in Local Currency Unit) in Cameroon in 1991 to that in 1997?
Provide a short and direct response. 0.59. What is the ratio of the Exports (in Local Currency Unit) in Jordan in 1991 to that in 1997?
Make the answer very short. 0.67. What is the ratio of the Exports (in Local Currency Unit) of St. Lucia in 1991 to that in 1997?
Your answer should be very brief. 0.84. What is the ratio of the Exports (in Local Currency Unit) in Sudan in 1991 to that in 1997?
Your answer should be compact. 0.01. What is the ratio of the Exports (in Local Currency Unit) of Cameroon in 1991 to that in 1998?
Your answer should be very brief. 0.54. What is the ratio of the Exports (in Local Currency Unit) of Jordan in 1991 to that in 1998?
Offer a terse response. 0.67. What is the ratio of the Exports (in Local Currency Unit) of St. Lucia in 1991 to that in 1998?
Your response must be concise. 0.79. What is the ratio of the Exports (in Local Currency Unit) of Sudan in 1991 to that in 1998?
Give a very brief answer. 0.01. What is the ratio of the Exports (in Local Currency Unit) in Cameroon in 1992 to that in 1993?
Your answer should be compact. 1.13. What is the ratio of the Exports (in Local Currency Unit) of Jordan in 1992 to that in 1993?
Keep it short and to the point. 0.93. What is the ratio of the Exports (in Local Currency Unit) in St. Lucia in 1992 to that in 1993?
Your answer should be compact. 0.97. What is the ratio of the Exports (in Local Currency Unit) in Sudan in 1992 to that in 1993?
Provide a short and direct response. 0.6. What is the ratio of the Exports (in Local Currency Unit) of Cameroon in 1992 to that in 1994?
Give a very brief answer. 0.78. What is the ratio of the Exports (in Local Currency Unit) in Jordan in 1992 to that in 1994?
Ensure brevity in your answer.  0.87. What is the ratio of the Exports (in Local Currency Unit) in Sudan in 1992 to that in 1994?
Make the answer very short. 0.21. What is the ratio of the Exports (in Local Currency Unit) of Cameroon in 1992 to that in 1995?
Keep it short and to the point. 0.61. What is the ratio of the Exports (in Local Currency Unit) of Jordan in 1992 to that in 1995?
Your response must be concise. 0.74. What is the ratio of the Exports (in Local Currency Unit) of St. Lucia in 1992 to that in 1995?
Provide a short and direct response. 0.85. What is the ratio of the Exports (in Local Currency Unit) of Sudan in 1992 to that in 1995?
Your response must be concise. 0.09. What is the ratio of the Exports (in Local Currency Unit) of Cameroon in 1992 to that in 1996?
Offer a very short reply. 0.57. What is the ratio of the Exports (in Local Currency Unit) in Jordan in 1992 to that in 1996?
Ensure brevity in your answer.  0.7. What is the ratio of the Exports (in Local Currency Unit) in St. Lucia in 1992 to that in 1996?
Keep it short and to the point. 0.92. What is the ratio of the Exports (in Local Currency Unit) in Sudan in 1992 to that in 1996?
Your response must be concise. 0.04. What is the ratio of the Exports (in Local Currency Unit) of Cameroon in 1992 to that in 1997?
Keep it short and to the point. 0.58. What is the ratio of the Exports (in Local Currency Unit) of Jordan in 1992 to that in 1997?
Make the answer very short. 0.72. What is the ratio of the Exports (in Local Currency Unit) in St. Lucia in 1992 to that in 1997?
Offer a very short reply. 0.9. What is the ratio of the Exports (in Local Currency Unit) of Sudan in 1992 to that in 1997?
Provide a short and direct response. 0.04. What is the ratio of the Exports (in Local Currency Unit) of Cameroon in 1992 to that in 1998?
Your answer should be very brief. 0.53. What is the ratio of the Exports (in Local Currency Unit) in Jordan in 1992 to that in 1998?
Your answer should be very brief. 0.72. What is the ratio of the Exports (in Local Currency Unit) of St. Lucia in 1992 to that in 1998?
Provide a succinct answer. 0.84. What is the ratio of the Exports (in Local Currency Unit) of Sudan in 1992 to that in 1998?
Offer a terse response. 0.02. What is the ratio of the Exports (in Local Currency Unit) in Cameroon in 1993 to that in 1994?
Your response must be concise. 0.69. What is the ratio of the Exports (in Local Currency Unit) of St. Lucia in 1993 to that in 1994?
Keep it short and to the point. 0.98. What is the ratio of the Exports (in Local Currency Unit) of Sudan in 1993 to that in 1994?
Provide a short and direct response. 0.34. What is the ratio of the Exports (in Local Currency Unit) in Cameroon in 1993 to that in 1995?
Offer a very short reply. 0.54. What is the ratio of the Exports (in Local Currency Unit) in Jordan in 1993 to that in 1995?
Your answer should be very brief. 0.8. What is the ratio of the Exports (in Local Currency Unit) in St. Lucia in 1993 to that in 1995?
Ensure brevity in your answer.  0.88. What is the ratio of the Exports (in Local Currency Unit) in Sudan in 1993 to that in 1995?
Provide a short and direct response. 0.15. What is the ratio of the Exports (in Local Currency Unit) of Cameroon in 1993 to that in 1996?
Ensure brevity in your answer.  0.51. What is the ratio of the Exports (in Local Currency Unit) of Jordan in 1993 to that in 1996?
Your answer should be very brief. 0.75. What is the ratio of the Exports (in Local Currency Unit) of St. Lucia in 1993 to that in 1996?
Provide a short and direct response. 0.94. What is the ratio of the Exports (in Local Currency Unit) of Sudan in 1993 to that in 1996?
Ensure brevity in your answer.  0.07. What is the ratio of the Exports (in Local Currency Unit) in Cameroon in 1993 to that in 1997?
Offer a terse response. 0.51. What is the ratio of the Exports (in Local Currency Unit) of Jordan in 1993 to that in 1997?
Provide a succinct answer. 0.77. What is the ratio of the Exports (in Local Currency Unit) in St. Lucia in 1993 to that in 1997?
Your answer should be very brief. 0.93. What is the ratio of the Exports (in Local Currency Unit) of Sudan in 1993 to that in 1997?
Provide a short and direct response. 0.06. What is the ratio of the Exports (in Local Currency Unit) of Cameroon in 1993 to that in 1998?
Give a very brief answer. 0.47. What is the ratio of the Exports (in Local Currency Unit) of Jordan in 1993 to that in 1998?
Your answer should be compact. 0.78. What is the ratio of the Exports (in Local Currency Unit) of St. Lucia in 1993 to that in 1998?
Keep it short and to the point. 0.87. What is the ratio of the Exports (in Local Currency Unit) in Sudan in 1993 to that in 1998?
Offer a terse response. 0.04. What is the ratio of the Exports (in Local Currency Unit) of Cameroon in 1994 to that in 1995?
Provide a succinct answer. 0.79. What is the ratio of the Exports (in Local Currency Unit) of Jordan in 1994 to that in 1995?
Make the answer very short. 0.86. What is the ratio of the Exports (in Local Currency Unit) of St. Lucia in 1994 to that in 1995?
Your answer should be very brief. 0.9. What is the ratio of the Exports (in Local Currency Unit) in Sudan in 1994 to that in 1995?
Provide a short and direct response. 0.44. What is the ratio of the Exports (in Local Currency Unit) of Cameroon in 1994 to that in 1996?
Make the answer very short. 0.74. What is the ratio of the Exports (in Local Currency Unit) of Jordan in 1994 to that in 1996?
Your answer should be very brief. 0.8. What is the ratio of the Exports (in Local Currency Unit) in St. Lucia in 1994 to that in 1996?
Your answer should be very brief. 0.96. What is the ratio of the Exports (in Local Currency Unit) in Sudan in 1994 to that in 1996?
Make the answer very short. 0.21. What is the ratio of the Exports (in Local Currency Unit) of Cameroon in 1994 to that in 1997?
Give a very brief answer. 0.74. What is the ratio of the Exports (in Local Currency Unit) of Jordan in 1994 to that in 1997?
Ensure brevity in your answer.  0.82. What is the ratio of the Exports (in Local Currency Unit) of St. Lucia in 1994 to that in 1997?
Provide a succinct answer. 0.95. What is the ratio of the Exports (in Local Currency Unit) of Sudan in 1994 to that in 1997?
Provide a short and direct response. 0.18. What is the ratio of the Exports (in Local Currency Unit) in Cameroon in 1994 to that in 1998?
Provide a short and direct response. 0.68. What is the ratio of the Exports (in Local Currency Unit) in Jordan in 1994 to that in 1998?
Your response must be concise. 0.83. What is the ratio of the Exports (in Local Currency Unit) of St. Lucia in 1994 to that in 1998?
Offer a very short reply. 0.89. What is the ratio of the Exports (in Local Currency Unit) of Sudan in 1994 to that in 1998?
Your response must be concise. 0.11. What is the ratio of the Exports (in Local Currency Unit) of Cameroon in 1995 to that in 1996?
Offer a terse response. 0.94. What is the ratio of the Exports (in Local Currency Unit) in Jordan in 1995 to that in 1996?
Provide a succinct answer. 0.94. What is the ratio of the Exports (in Local Currency Unit) in St. Lucia in 1995 to that in 1996?
Keep it short and to the point. 1.07. What is the ratio of the Exports (in Local Currency Unit) in Sudan in 1995 to that in 1996?
Your answer should be very brief. 0.47. What is the ratio of the Exports (in Local Currency Unit) in Cameroon in 1995 to that in 1997?
Offer a terse response. 0.94. What is the ratio of the Exports (in Local Currency Unit) in Jordan in 1995 to that in 1997?
Ensure brevity in your answer.  0.96. What is the ratio of the Exports (in Local Currency Unit) of St. Lucia in 1995 to that in 1997?
Give a very brief answer. 1.06. What is the ratio of the Exports (in Local Currency Unit) in Sudan in 1995 to that in 1997?
Your answer should be compact. 0.41. What is the ratio of the Exports (in Local Currency Unit) in Cameroon in 1995 to that in 1998?
Your answer should be compact. 0.86. What is the ratio of the Exports (in Local Currency Unit) in Jordan in 1995 to that in 1998?
Ensure brevity in your answer.  0.97. What is the ratio of the Exports (in Local Currency Unit) of St. Lucia in 1995 to that in 1998?
Give a very brief answer. 0.99. What is the ratio of the Exports (in Local Currency Unit) of Sudan in 1995 to that in 1998?
Your answer should be compact. 0.26. What is the ratio of the Exports (in Local Currency Unit) of Jordan in 1996 to that in 1997?
Offer a very short reply. 1.03. What is the ratio of the Exports (in Local Currency Unit) of St. Lucia in 1996 to that in 1997?
Provide a short and direct response. 0.98. What is the ratio of the Exports (in Local Currency Unit) of Sudan in 1996 to that in 1997?
Provide a succinct answer. 0.85. What is the ratio of the Exports (in Local Currency Unit) in Cameroon in 1996 to that in 1998?
Your answer should be compact. 0.92. What is the ratio of the Exports (in Local Currency Unit) of Jordan in 1996 to that in 1998?
Provide a succinct answer. 1.03. What is the ratio of the Exports (in Local Currency Unit) in St. Lucia in 1996 to that in 1998?
Offer a very short reply. 0.92. What is the ratio of the Exports (in Local Currency Unit) of Sudan in 1996 to that in 1998?
Provide a short and direct response. 0.56. What is the ratio of the Exports (in Local Currency Unit) of Cameroon in 1997 to that in 1998?
Make the answer very short. 0.92. What is the ratio of the Exports (in Local Currency Unit) in Jordan in 1997 to that in 1998?
Your answer should be compact. 1.01. What is the ratio of the Exports (in Local Currency Unit) in St. Lucia in 1997 to that in 1998?
Your response must be concise. 0.93. What is the ratio of the Exports (in Local Currency Unit) in Sudan in 1997 to that in 1998?
Provide a succinct answer. 0.65. What is the difference between the highest and the second highest Exports (in Local Currency Unit) in Cameroon?
Your response must be concise. 1.01e+11. What is the difference between the highest and the second highest Exports (in Local Currency Unit) of Jordan?
Offer a terse response. 6.44e+07. What is the difference between the highest and the second highest Exports (in Local Currency Unit) in St. Lucia?
Your response must be concise. 1.45e+07. What is the difference between the highest and the second highest Exports (in Local Currency Unit) of Sudan?
Provide a succinct answer. 5.30e+08. What is the difference between the highest and the lowest Exports (in Local Currency Unit) in Cameroon?
Provide a short and direct response. 6.62e+11. What is the difference between the highest and the lowest Exports (in Local Currency Unit) of Jordan?
Your response must be concise. 9.00e+08. What is the difference between the highest and the lowest Exports (in Local Currency Unit) of St. Lucia?
Make the answer very short. 2.23e+08. What is the difference between the highest and the lowest Exports (in Local Currency Unit) of Sudan?
Ensure brevity in your answer.  1.50e+09. 